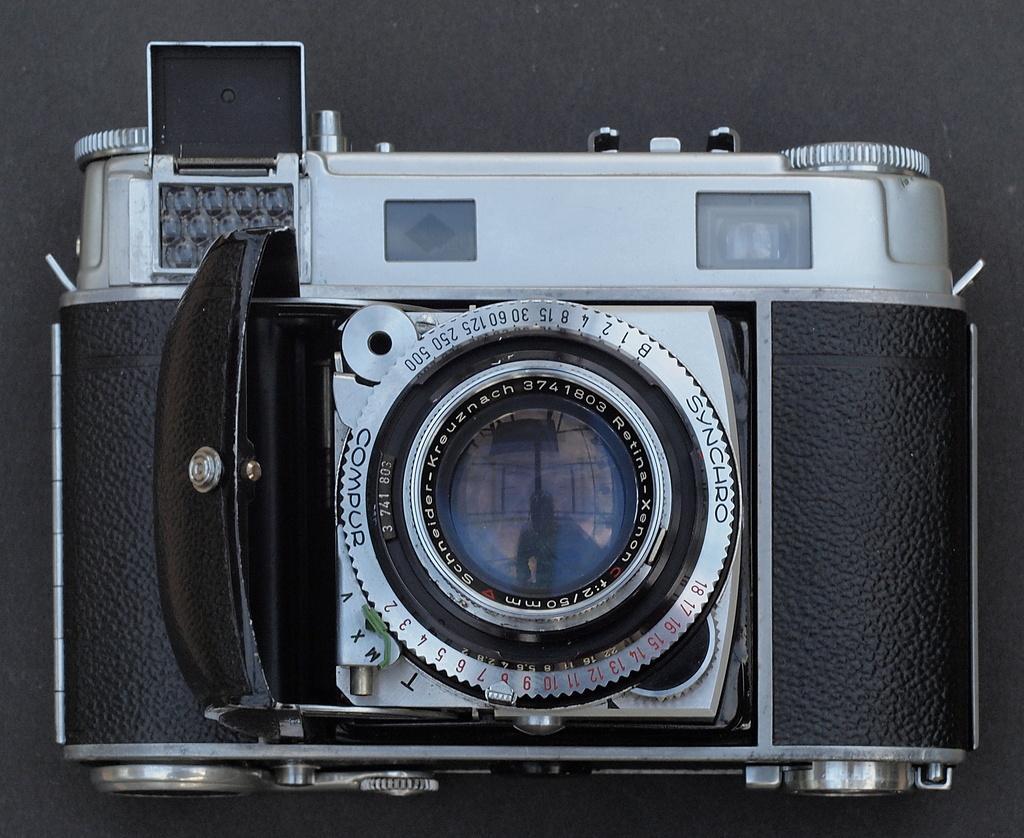Please provide a concise description of this image. In this image I can see the camera in black and silver color and the background is in black color. 